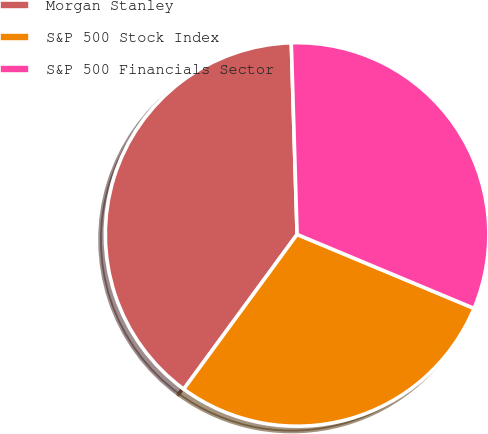Convert chart to OTSL. <chart><loc_0><loc_0><loc_500><loc_500><pie_chart><fcel>Morgan Stanley<fcel>S&P 500 Stock Index<fcel>S&P 500 Financials Sector<nl><fcel>39.45%<fcel>28.76%<fcel>31.78%<nl></chart> 